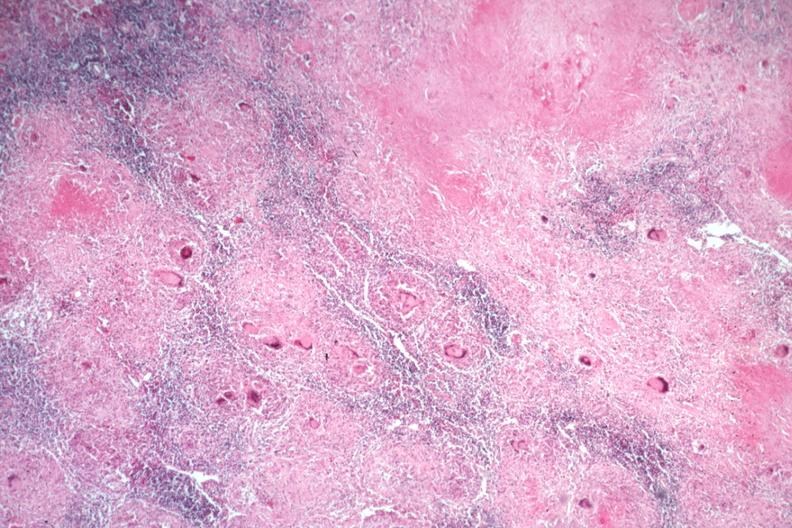does this image show typical caseating lesions with many langerhans giant cells?
Answer the question using a single word or phrase. Yes 